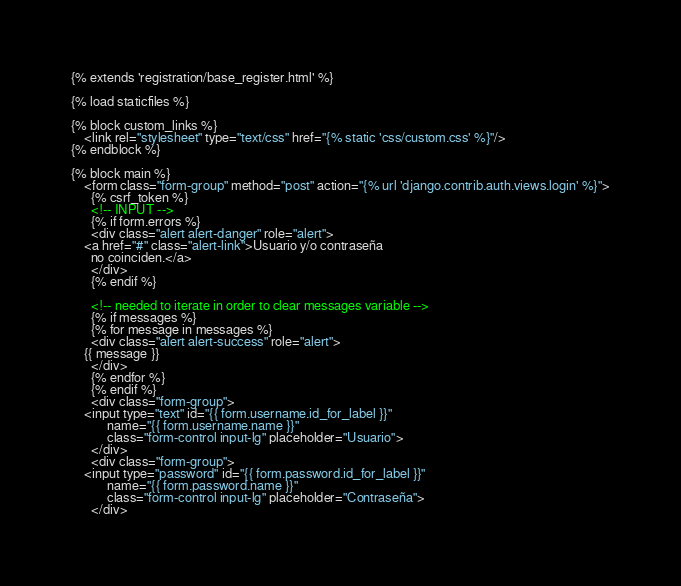<code> <loc_0><loc_0><loc_500><loc_500><_HTML_>{% extends 'registration/base_register.html' %}

{% load staticfiles %}

{% block custom_links %}
    <link rel="stylesheet" type="text/css" href="{% static 'css/custom.css' %}"/>
{% endblock %}

{% block main %}
    <form class="form-group" method="post" action="{% url 'django.contrib.auth.views.login' %}">
      {% csrf_token %}
      <!-- INPUT -->
      {% if form.errors %}
      <div class="alert alert-danger" role="alert">
	<a href="#" class="alert-link">Usuario y/o contraseña
	  no coinciden.</a>
      </div>	  
      {% endif %}

      <!-- needed to iterate in order to clear messages variable -->
      {% if messages %}
      {% for message in messages %}
      <div class="alert alert-success" role="alert">
	{{ message }}
      </div>
      {% endfor %}
      {% endif %}
      <div class="form-group">
	<input type="text" id="{{ form.username.id_for_label }}"
	       name="{{ form.username.name }}"
	       class="form-control input-lg" placeholder="Usuario">
      </div>
      <div class="form-group">
	<input type="password" id="{{ form.password.id_for_label }}"
	       name="{{ form.password.name }}"
	       class="form-control input-lg" placeholder="Contraseña">
      </div></code> 